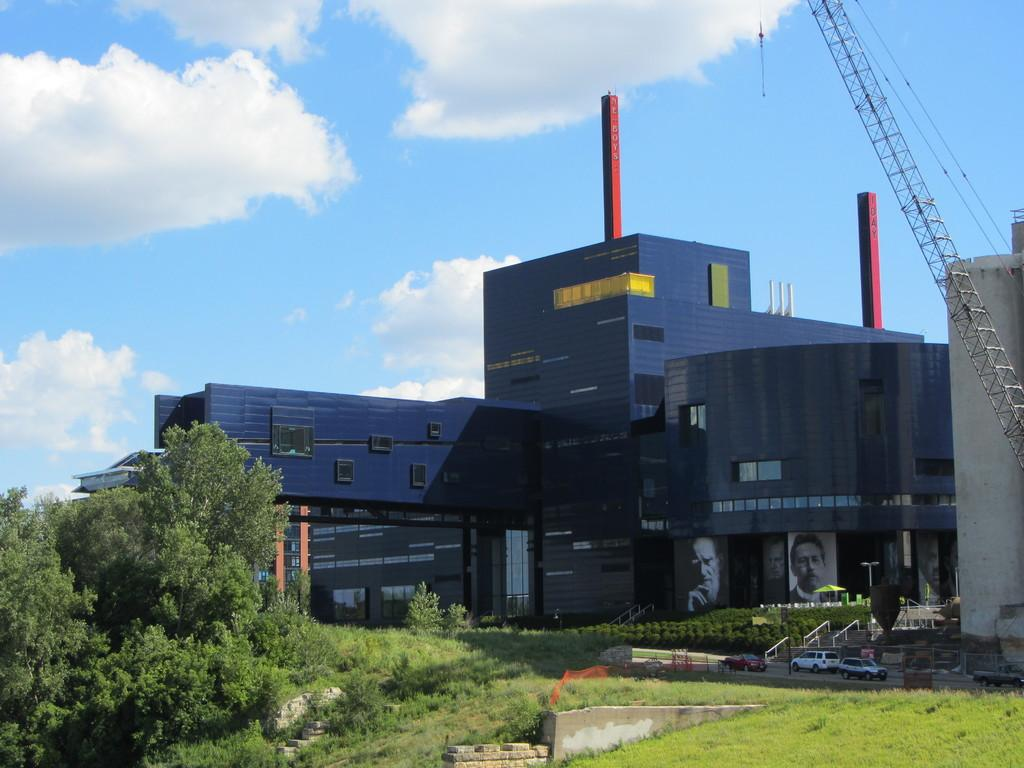What type of natural environment is depicted in the image? The image contains grass, trees, and plants, which are all elements of a natural environment. What man-made structures can be seen in the image? There are vehicles, banners, and buildings visible in the image. What is visible in the sky in the image? The sky is visible in the image, and clouds are present. How many jellyfish can be seen swimming in the grass in the image? There are no jellyfish present in the image, as it depicts a natural environment with grass, trees, and plants. 